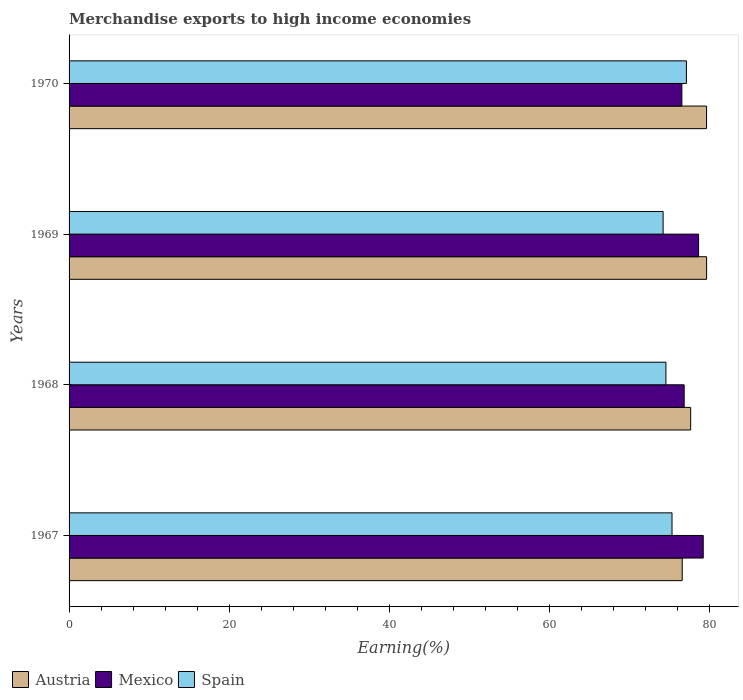Are the number of bars per tick equal to the number of legend labels?
Your response must be concise. Yes. How many bars are there on the 3rd tick from the top?
Provide a succinct answer. 3. How many bars are there on the 3rd tick from the bottom?
Give a very brief answer. 3. What is the percentage of amount earned from merchandise exports in Spain in 1968?
Your answer should be compact. 74.58. Across all years, what is the maximum percentage of amount earned from merchandise exports in Mexico?
Offer a very short reply. 79.24. Across all years, what is the minimum percentage of amount earned from merchandise exports in Austria?
Provide a succinct answer. 76.61. In which year was the percentage of amount earned from merchandise exports in Mexico maximum?
Your answer should be very brief. 1967. In which year was the percentage of amount earned from merchandise exports in Spain minimum?
Ensure brevity in your answer.  1969. What is the total percentage of amount earned from merchandise exports in Austria in the graph?
Your response must be concise. 313.59. What is the difference between the percentage of amount earned from merchandise exports in Spain in 1967 and that in 1970?
Make the answer very short. -1.8. What is the difference between the percentage of amount earned from merchandise exports in Austria in 1967 and the percentage of amount earned from merchandise exports in Mexico in 1969?
Your answer should be very brief. -2.05. What is the average percentage of amount earned from merchandise exports in Spain per year?
Provide a short and direct response. 75.32. In the year 1967, what is the difference between the percentage of amount earned from merchandise exports in Spain and percentage of amount earned from merchandise exports in Mexico?
Your answer should be compact. -3.9. In how many years, is the percentage of amount earned from merchandise exports in Spain greater than 52 %?
Your answer should be very brief. 4. What is the ratio of the percentage of amount earned from merchandise exports in Austria in 1969 to that in 1970?
Offer a very short reply. 1. What is the difference between the highest and the second highest percentage of amount earned from merchandise exports in Spain?
Give a very brief answer. 1.8. What is the difference between the highest and the lowest percentage of amount earned from merchandise exports in Austria?
Your answer should be compact. 3.05. In how many years, is the percentage of amount earned from merchandise exports in Mexico greater than the average percentage of amount earned from merchandise exports in Mexico taken over all years?
Keep it short and to the point. 2. What does the 2nd bar from the bottom in 1968 represents?
Your answer should be very brief. Mexico. How many bars are there?
Provide a short and direct response. 12. How many years are there in the graph?
Offer a very short reply. 4. Does the graph contain any zero values?
Give a very brief answer. No. Where does the legend appear in the graph?
Offer a terse response. Bottom left. How many legend labels are there?
Your answer should be compact. 3. How are the legend labels stacked?
Offer a very short reply. Horizontal. What is the title of the graph?
Ensure brevity in your answer.  Merchandise exports to high income economies. Does "Liberia" appear as one of the legend labels in the graph?
Offer a terse response. No. What is the label or title of the X-axis?
Your answer should be compact. Earning(%). What is the Earning(%) of Austria in 1967?
Give a very brief answer. 76.61. What is the Earning(%) in Mexico in 1967?
Your response must be concise. 79.24. What is the Earning(%) in Spain in 1967?
Your answer should be very brief. 75.34. What is the Earning(%) of Austria in 1968?
Provide a succinct answer. 77.67. What is the Earning(%) of Mexico in 1968?
Keep it short and to the point. 76.86. What is the Earning(%) in Spain in 1968?
Keep it short and to the point. 74.58. What is the Earning(%) in Austria in 1969?
Your response must be concise. 79.66. What is the Earning(%) in Mexico in 1969?
Offer a terse response. 78.66. What is the Earning(%) of Spain in 1969?
Provide a succinct answer. 74.22. What is the Earning(%) of Austria in 1970?
Your response must be concise. 79.65. What is the Earning(%) in Mexico in 1970?
Provide a short and direct response. 76.57. What is the Earning(%) of Spain in 1970?
Your response must be concise. 77.14. Across all years, what is the maximum Earning(%) in Austria?
Offer a terse response. 79.66. Across all years, what is the maximum Earning(%) of Mexico?
Offer a very short reply. 79.24. Across all years, what is the maximum Earning(%) of Spain?
Offer a very short reply. 77.14. Across all years, what is the minimum Earning(%) of Austria?
Offer a very short reply. 76.61. Across all years, what is the minimum Earning(%) in Mexico?
Your response must be concise. 76.57. Across all years, what is the minimum Earning(%) of Spain?
Your response must be concise. 74.22. What is the total Earning(%) in Austria in the graph?
Your answer should be very brief. 313.59. What is the total Earning(%) in Mexico in the graph?
Offer a very short reply. 311.32. What is the total Earning(%) of Spain in the graph?
Make the answer very short. 301.27. What is the difference between the Earning(%) of Austria in 1967 and that in 1968?
Ensure brevity in your answer.  -1.06. What is the difference between the Earning(%) in Mexico in 1967 and that in 1968?
Offer a very short reply. 2.38. What is the difference between the Earning(%) in Spain in 1967 and that in 1968?
Offer a very short reply. 0.76. What is the difference between the Earning(%) of Austria in 1967 and that in 1969?
Keep it short and to the point. -3.05. What is the difference between the Earning(%) of Mexico in 1967 and that in 1969?
Offer a very short reply. 0.58. What is the difference between the Earning(%) in Spain in 1967 and that in 1969?
Ensure brevity in your answer.  1.11. What is the difference between the Earning(%) of Austria in 1967 and that in 1970?
Your answer should be compact. -3.04. What is the difference between the Earning(%) of Mexico in 1967 and that in 1970?
Provide a succinct answer. 2.67. What is the difference between the Earning(%) in Spain in 1967 and that in 1970?
Provide a short and direct response. -1.8. What is the difference between the Earning(%) in Austria in 1968 and that in 1969?
Offer a terse response. -1.99. What is the difference between the Earning(%) in Mexico in 1968 and that in 1969?
Offer a terse response. -1.8. What is the difference between the Earning(%) in Spain in 1968 and that in 1969?
Make the answer very short. 0.35. What is the difference between the Earning(%) in Austria in 1968 and that in 1970?
Offer a terse response. -1.98. What is the difference between the Earning(%) in Mexico in 1968 and that in 1970?
Ensure brevity in your answer.  0.29. What is the difference between the Earning(%) of Spain in 1968 and that in 1970?
Offer a terse response. -2.56. What is the difference between the Earning(%) in Austria in 1969 and that in 1970?
Ensure brevity in your answer.  0.01. What is the difference between the Earning(%) in Mexico in 1969 and that in 1970?
Provide a short and direct response. 2.09. What is the difference between the Earning(%) in Spain in 1969 and that in 1970?
Ensure brevity in your answer.  -2.91. What is the difference between the Earning(%) of Austria in 1967 and the Earning(%) of Mexico in 1968?
Provide a short and direct response. -0.24. What is the difference between the Earning(%) in Austria in 1967 and the Earning(%) in Spain in 1968?
Provide a succinct answer. 2.04. What is the difference between the Earning(%) in Mexico in 1967 and the Earning(%) in Spain in 1968?
Give a very brief answer. 4.66. What is the difference between the Earning(%) in Austria in 1967 and the Earning(%) in Mexico in 1969?
Your answer should be compact. -2.05. What is the difference between the Earning(%) in Austria in 1967 and the Earning(%) in Spain in 1969?
Offer a very short reply. 2.39. What is the difference between the Earning(%) of Mexico in 1967 and the Earning(%) of Spain in 1969?
Make the answer very short. 5.01. What is the difference between the Earning(%) of Austria in 1967 and the Earning(%) of Mexico in 1970?
Offer a very short reply. 0.04. What is the difference between the Earning(%) in Austria in 1967 and the Earning(%) in Spain in 1970?
Offer a very short reply. -0.53. What is the difference between the Earning(%) of Mexico in 1967 and the Earning(%) of Spain in 1970?
Make the answer very short. 2.1. What is the difference between the Earning(%) of Austria in 1968 and the Earning(%) of Mexico in 1969?
Your answer should be very brief. -0.99. What is the difference between the Earning(%) in Austria in 1968 and the Earning(%) in Spain in 1969?
Keep it short and to the point. 3.44. What is the difference between the Earning(%) of Mexico in 1968 and the Earning(%) of Spain in 1969?
Offer a very short reply. 2.63. What is the difference between the Earning(%) of Austria in 1968 and the Earning(%) of Mexico in 1970?
Your answer should be compact. 1.1. What is the difference between the Earning(%) of Austria in 1968 and the Earning(%) of Spain in 1970?
Offer a very short reply. 0.53. What is the difference between the Earning(%) of Mexico in 1968 and the Earning(%) of Spain in 1970?
Ensure brevity in your answer.  -0.28. What is the difference between the Earning(%) in Austria in 1969 and the Earning(%) in Mexico in 1970?
Make the answer very short. 3.09. What is the difference between the Earning(%) of Austria in 1969 and the Earning(%) of Spain in 1970?
Offer a terse response. 2.52. What is the difference between the Earning(%) in Mexico in 1969 and the Earning(%) in Spain in 1970?
Offer a terse response. 1.52. What is the average Earning(%) of Austria per year?
Your answer should be compact. 78.4. What is the average Earning(%) of Mexico per year?
Make the answer very short. 77.83. What is the average Earning(%) of Spain per year?
Provide a succinct answer. 75.32. In the year 1967, what is the difference between the Earning(%) in Austria and Earning(%) in Mexico?
Keep it short and to the point. -2.63. In the year 1967, what is the difference between the Earning(%) in Austria and Earning(%) in Spain?
Your response must be concise. 1.27. In the year 1967, what is the difference between the Earning(%) of Mexico and Earning(%) of Spain?
Your answer should be very brief. 3.9. In the year 1968, what is the difference between the Earning(%) of Austria and Earning(%) of Mexico?
Make the answer very short. 0.81. In the year 1968, what is the difference between the Earning(%) of Austria and Earning(%) of Spain?
Make the answer very short. 3.09. In the year 1968, what is the difference between the Earning(%) in Mexico and Earning(%) in Spain?
Provide a short and direct response. 2.28. In the year 1969, what is the difference between the Earning(%) of Austria and Earning(%) of Spain?
Ensure brevity in your answer.  5.43. In the year 1969, what is the difference between the Earning(%) of Mexico and Earning(%) of Spain?
Your answer should be very brief. 4.43. In the year 1970, what is the difference between the Earning(%) in Austria and Earning(%) in Mexico?
Offer a terse response. 3.08. In the year 1970, what is the difference between the Earning(%) in Austria and Earning(%) in Spain?
Your response must be concise. 2.51. In the year 1970, what is the difference between the Earning(%) in Mexico and Earning(%) in Spain?
Your answer should be compact. -0.57. What is the ratio of the Earning(%) in Austria in 1967 to that in 1968?
Offer a terse response. 0.99. What is the ratio of the Earning(%) in Mexico in 1967 to that in 1968?
Provide a succinct answer. 1.03. What is the ratio of the Earning(%) in Spain in 1967 to that in 1968?
Ensure brevity in your answer.  1.01. What is the ratio of the Earning(%) in Austria in 1967 to that in 1969?
Provide a succinct answer. 0.96. What is the ratio of the Earning(%) of Mexico in 1967 to that in 1969?
Provide a short and direct response. 1.01. What is the ratio of the Earning(%) in Austria in 1967 to that in 1970?
Offer a terse response. 0.96. What is the ratio of the Earning(%) of Mexico in 1967 to that in 1970?
Your answer should be very brief. 1.03. What is the ratio of the Earning(%) of Spain in 1967 to that in 1970?
Keep it short and to the point. 0.98. What is the ratio of the Earning(%) in Mexico in 1968 to that in 1969?
Make the answer very short. 0.98. What is the ratio of the Earning(%) of Spain in 1968 to that in 1969?
Keep it short and to the point. 1. What is the ratio of the Earning(%) of Austria in 1968 to that in 1970?
Your response must be concise. 0.98. What is the ratio of the Earning(%) in Mexico in 1968 to that in 1970?
Ensure brevity in your answer.  1. What is the ratio of the Earning(%) in Spain in 1968 to that in 1970?
Give a very brief answer. 0.97. What is the ratio of the Earning(%) of Austria in 1969 to that in 1970?
Your answer should be compact. 1. What is the ratio of the Earning(%) in Mexico in 1969 to that in 1970?
Offer a terse response. 1.03. What is the ratio of the Earning(%) in Spain in 1969 to that in 1970?
Provide a succinct answer. 0.96. What is the difference between the highest and the second highest Earning(%) in Austria?
Provide a succinct answer. 0.01. What is the difference between the highest and the second highest Earning(%) in Mexico?
Offer a terse response. 0.58. What is the difference between the highest and the second highest Earning(%) of Spain?
Offer a terse response. 1.8. What is the difference between the highest and the lowest Earning(%) of Austria?
Your response must be concise. 3.05. What is the difference between the highest and the lowest Earning(%) of Mexico?
Provide a succinct answer. 2.67. What is the difference between the highest and the lowest Earning(%) in Spain?
Give a very brief answer. 2.91. 